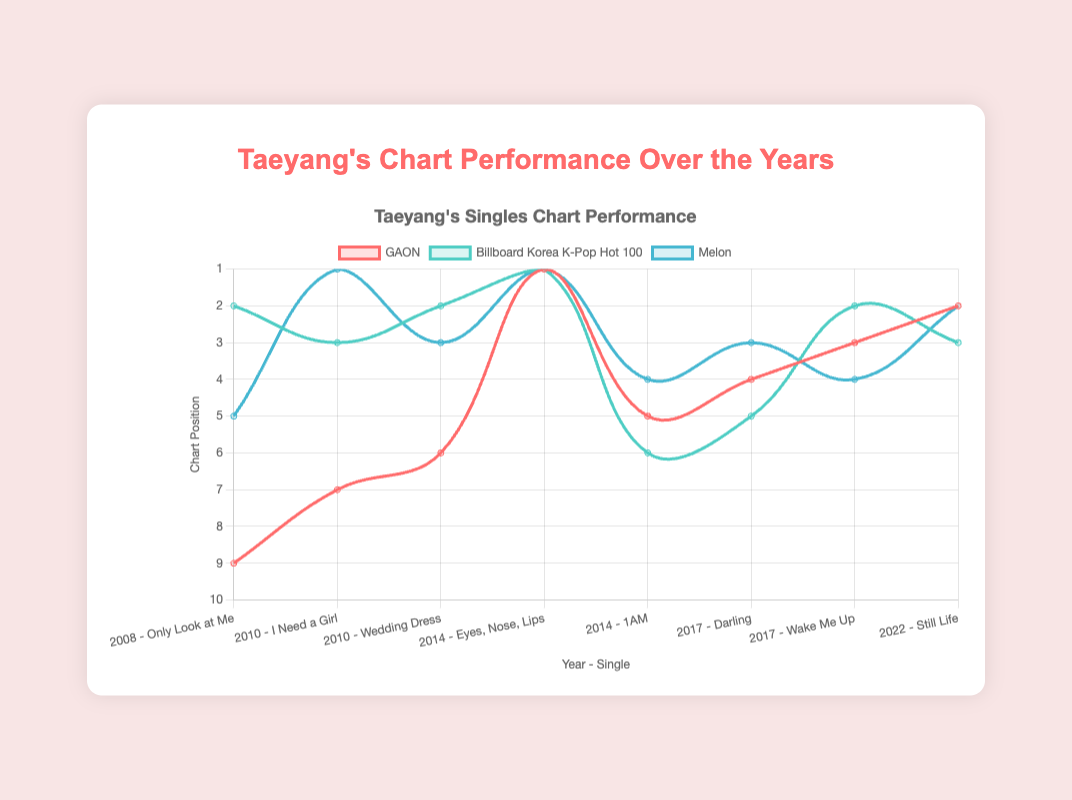What was Taeyang's best single in terms of chart performance on the Gaon chart? The best chart performance corresponds to the lowest number on the y-axis. "Eyes, Nose, Lips" in 2014 hit number 1, the highest possible ranking.
Answer: "Eyes, Nose, Lips" Which single performed equally well on both the Billboard Korea K-Pop Hot 100 and Melon charts? Look for lines that intersect at the same points on both the Billboard Korea K-Pop Hot 100 and Melon charts. "I Need a Girl" in 2010 holds the same rank of 3 on both.
Answer: "I Need a Girl" How did the chart performance of "Darling" in 2017 compare to "1AM" in 2014 on the GAON chart? Compare the positions on the GAON chart for both singles. "Darling" ranked 4 while "1AM" ranked 5, so "Darling" performed slightly better.
Answer: "Darling performed better" Which album saw the most significant improvement in chart performance from its previous album on the GAON chart? Compare the rankings of singles from consecutive albums. "Rise" in 2014 performed better than "Solar" in 2010 with its single "Eyes, Nose, Lips" hitting number 1, a prominent improvement.
Answer: "Rise" What was the average chart ranking of Taeyang's singles in 2010 on the Billboard Korea K-Pop Hot 100? The singles in 2010 are "I Need a Girl" and "Wedding Dress," ranked at 3 and 2 respectively. The average is (3 + 2)/2 = 2.5.
Answer: 2.5 Between "Eyes, Nose, Lips" and "Still Life," which showed more consistent chart performance across the three charts? Compare the spread of rankings for each single. "Eyes, Nose, Lips" had a uniform ranking of 1 on all charts, while "Still Life" varied slightly more with ranks 2, 3, and 2.
Answer: "Eyes, Nose, Lips" From 2008 to 2022, which single experienced the highest peak on the Melon chart? Identify the lowest number on the y-axis for the Melon chart. "Eyes, Nose, Lips" in 2014 hit number 1, the highest rank.
Answer: "Eyes, Nose, Lips" What is the sum of the Gaon chart rankings for Taeyang’s singles in 2017? The Gaon rankings for "Darling" and "Wake Me Up" in 2017 are 4 and 3 respectively. The sum is 4 + 3 = 7.
Answer: 7 Which year had the best average performance across all charts considering Taeyang's singles? Calculate the average ranking for each year across the three charts and compare. 2014 has singles "Eyes, Nose, Lips" (1, 1, 1) and "1AM" (5, 6, 4), averaging ((1+1+1)+(5+6+4))/6 = 3.
Answer: 2014 Which single achieved the same rank on the Gaon and Billboard Korea K-Pop Hot 100 charts in 2017? Look for the intersection points of the lines for Gaon and Billboard Korea K-Pop Hot 100 in 2017. "Wake Me Up" ranked 3 on Gaon and 2 on Billboard Korea K-Pop Hot 100, while "Darling" doesn’t have equal ranks.
Answer: None 